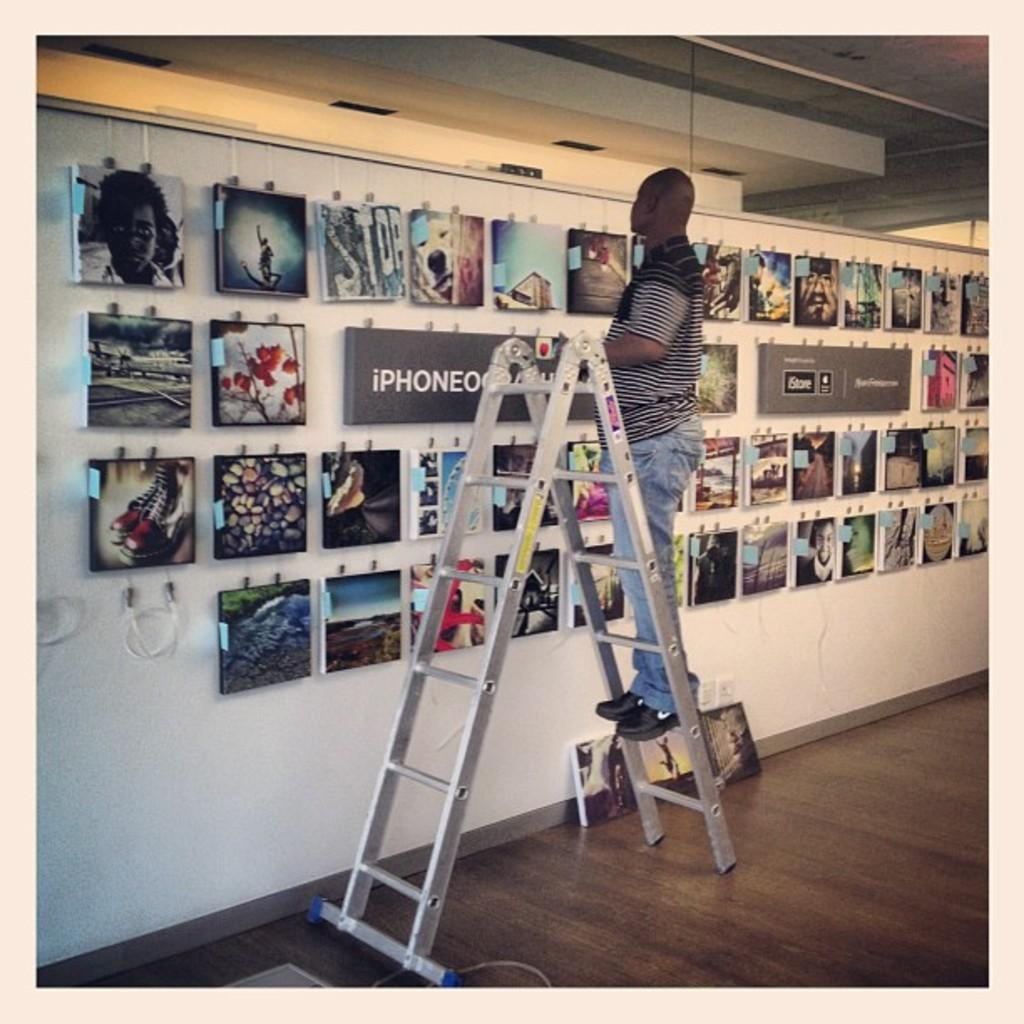Provide a one-sentence caption for the provided image. Man on a ladder in front of wall of pictures with the word IPhone. 